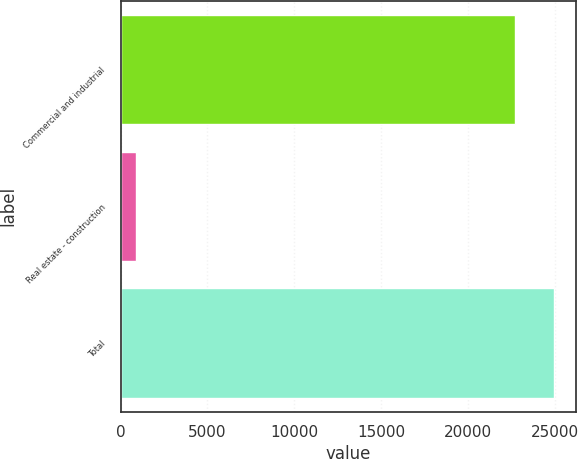<chart> <loc_0><loc_0><loc_500><loc_500><bar_chart><fcel>Commercial and industrial<fcel>Real estate - construction<fcel>Total<nl><fcel>22671<fcel>884<fcel>24938.1<nl></chart> 